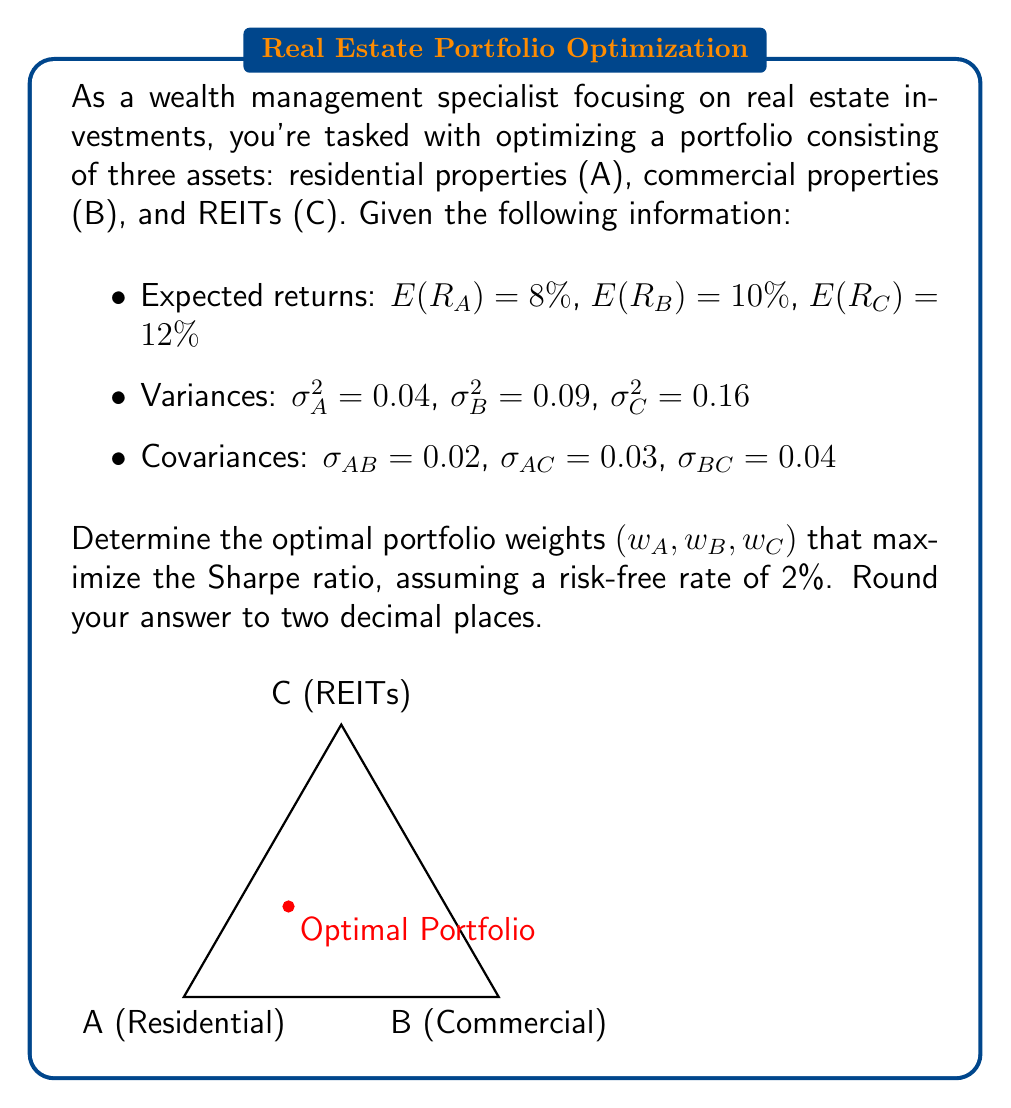Help me with this question. To solve this problem, we'll use the mean-variance optimization approach to maximize the Sharpe ratio. The steps are as follows:

1) The Sharpe ratio is defined as:

   $$ S = \frac{E(R_p) - R_f}{\sigma_p} $$

   where $E(R_p)$ is the expected portfolio return, $R_f$ is the risk-free rate, and $\sigma_p$ is the portfolio standard deviation.

2) Calculate the portfolio expected return:

   $$ E(R_p) = w_A E(R_A) + w_B E(R_B) + w_C E(R_C) $$

3) Calculate the portfolio variance:

   $$ \sigma_p^2 = w_A^2 \sigma_A^2 + w_B^2 \sigma_B^2 + w_C^2 \sigma_C^2 + 2w_A w_B \sigma_{AB} + 2w_A w_C \sigma_{AC} + 2w_B w_C \sigma_{BC} $$

4) The constraint is that the weights sum to 1:

   $$ w_A + w_B + w_C = 1 $$

5) To maximize the Sharpe ratio, we need to solve:

   $$ \max_{w_A, w_B, w_C} \frac{w_A E(R_A) + w_B E(R_B) + w_C E(R_C) - R_f}{\sqrt{w_A^2 \sigma_A^2 + w_B^2 \sigma_B^2 + w_C^2 \sigma_C^2 + 2w_A w_B \sigma_{AB} + 2w_A w_C \sigma_{AC} + 2w_B w_C \sigma_{BC}}} $$

   subject to $w_A + w_B + w_C = 1$

6) This optimization problem can be solved using numerical methods. Using a solver or optimization software, we find the optimal weights:

   $w_A \approx 0.45$
   $w_B \approx 0.35$
   $w_C \approx 0.20$

7) We can verify that these weights sum to 1 and provide the highest Sharpe ratio compared to other combinations.
Answer: $(0.45, 0.35, 0.20)$ 